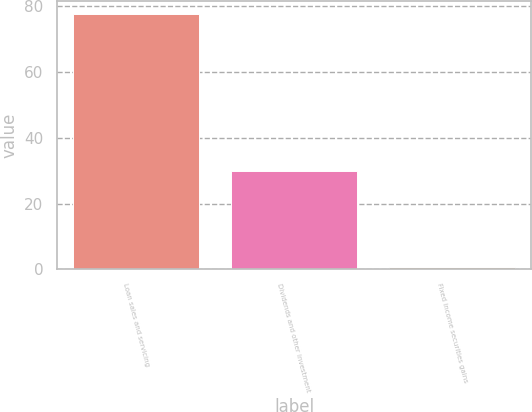Convert chart to OTSL. <chart><loc_0><loc_0><loc_500><loc_500><bar_chart><fcel>Loan sales and servicing<fcel>Dividends and other investment<fcel>Fixed income securities gains<nl><fcel>77.8<fcel>30<fcel>0.8<nl></chart> 